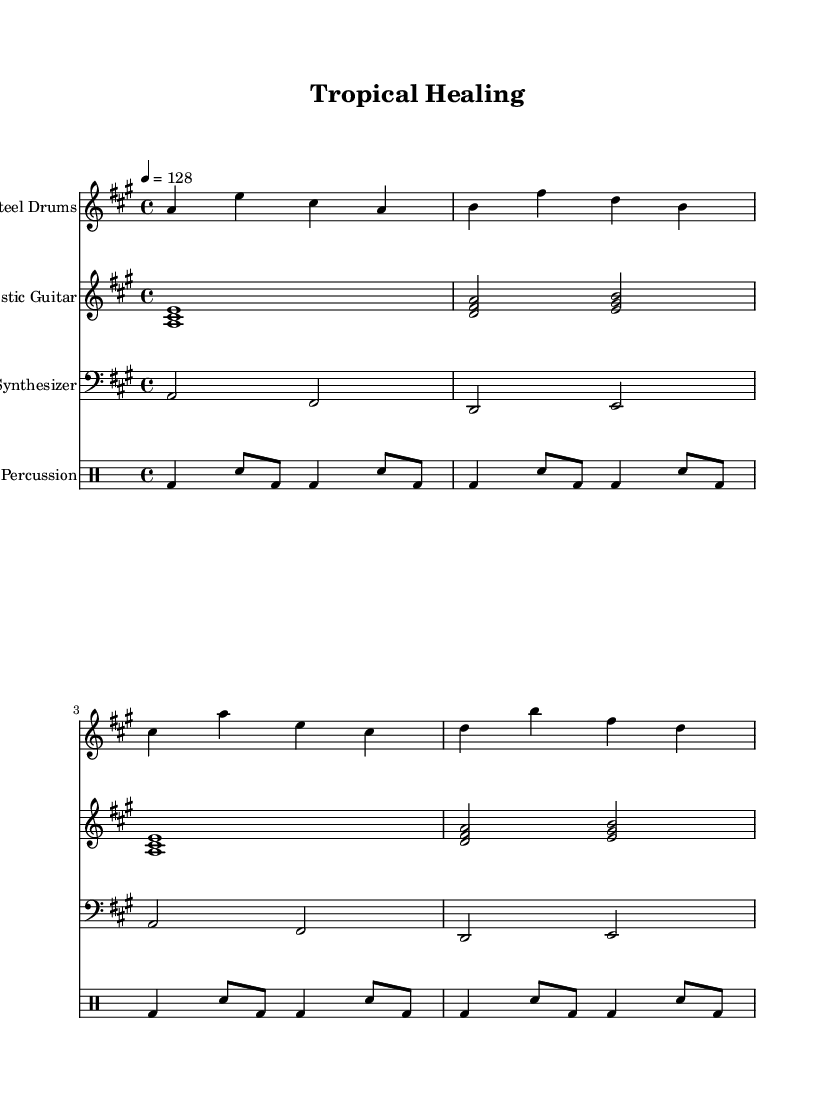What is the key signature of this music? The key signature is A major, indicated by three sharps (F#, C#, and G#) in the key signature at the beginning of the staff.
Answer: A major What is the time signature of the piece? The time signature is indicated by the "4/4" at the beginning of the score, meaning there are four beats in a measure and the quarter note gets one beat.
Answer: 4/4 What is the tempo marking for this piece? The tempo marking is indicated as "4 = 128", which specifies that there are 128 beats per minute, meaning the piece should be played at a moderate speed.
Answer: 128 What instruments are featured in this piece? The score features four instruments: Steel Drums, Acoustic Guitar, Synthesizer, and Percussion, as labeled at the beginning of each staff.
Answer: Steel Drums, Acoustic Guitar, Synthesizer, Percussion What is the rhythmic pattern of the percussion? The percussion part consists of a repeating pattern with bass drum and snare drum notes, creating a steady beat that contributes to the overall groove of the piece.
Answer: Repeating pattern How many measures are in the steel drums section? The steel drum section consists of four measures, each containing four beats as indicated by the time signature, making up a complete phrase.
Answer: Four measures How do the melodies reflect the tropical house genre? The melodies use bright, syncopated rhythms and incorporate steel drums, creating a light and uplifting vibe characteristic of tropical house music, blending organic sounds with electronic elements.
Answer: Bright and uplifting vibe 